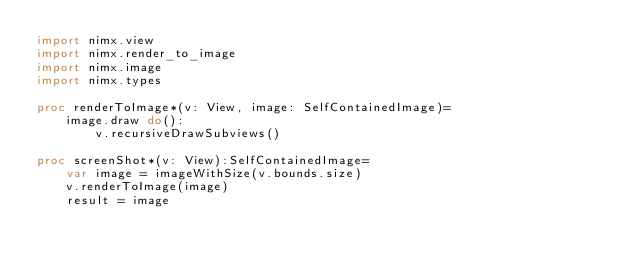Convert code to text. <code><loc_0><loc_0><loc_500><loc_500><_Nim_>import nimx.view
import nimx.render_to_image
import nimx.image
import nimx.types

proc renderToImage*(v: View, image: SelfContainedImage)=
    image.draw do():
        v.recursiveDrawSubviews()

proc screenShot*(v: View):SelfContainedImage=
    var image = imageWithSize(v.bounds.size)
    v.renderToImage(image)
    result = image

</code> 